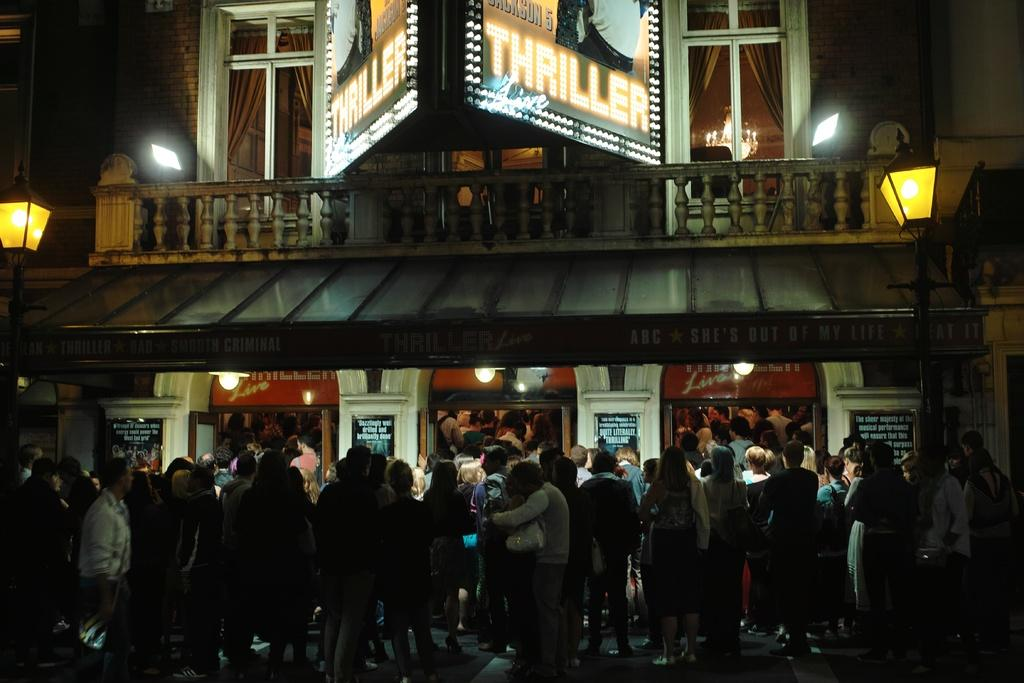<image>
Give a short and clear explanation of the subsequent image. Many people are lined up outside a theater to see Thriller. 